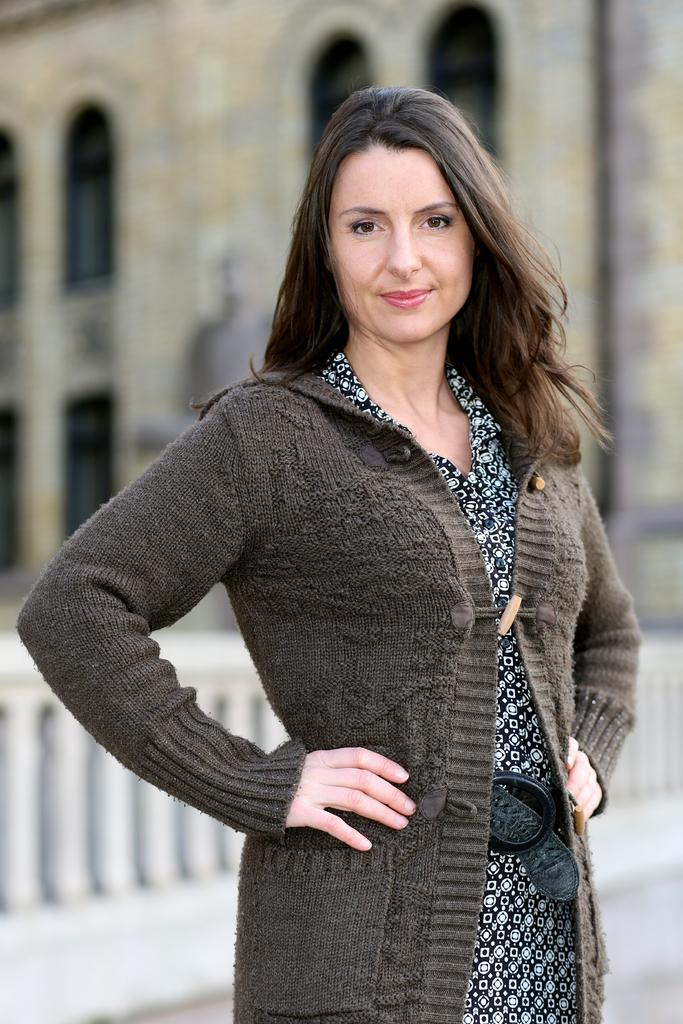What is the main subject in the image? There is a woman standing in the image. What can be seen in the background of the image? There is a building with windows and a fence in the background of the image. Is there a turkey visible in the background of the image? No, there is no turkey present in the image. 